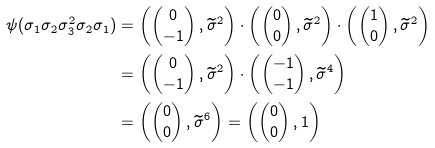Convert formula to latex. <formula><loc_0><loc_0><loc_500><loc_500>\psi ( \sigma _ { 1 } \sigma _ { 2 } \sigma _ { 3 } ^ { 2 } \sigma _ { 2 } \sigma _ { 1 } ) & = \left ( \begin{pmatrix} 0 \\ - 1 \end{pmatrix} , \widetilde { \sigma } ^ { 2 } \right ) \cdot \left ( \begin{pmatrix} 0 \\ 0 \end{pmatrix} , \widetilde { \sigma } ^ { 2 } \right ) \cdot \left ( \begin{pmatrix} 1 \\ 0 \end{pmatrix} , \widetilde { \sigma } ^ { 2 } \right ) \\ & = \left ( \begin{pmatrix} 0 \\ - 1 \end{pmatrix} , \widetilde { \sigma } ^ { 2 } \right ) \cdot \left ( \begin{pmatrix} - 1 \\ - 1 \end{pmatrix} , \widetilde { \sigma } ^ { 4 } \right ) \\ & = \left ( \begin{pmatrix} 0 \\ 0 \end{pmatrix} , \widetilde { \sigma } ^ { 6 } \right ) = \left ( \begin{pmatrix} 0 \\ 0 \end{pmatrix} , 1 \right )</formula> 